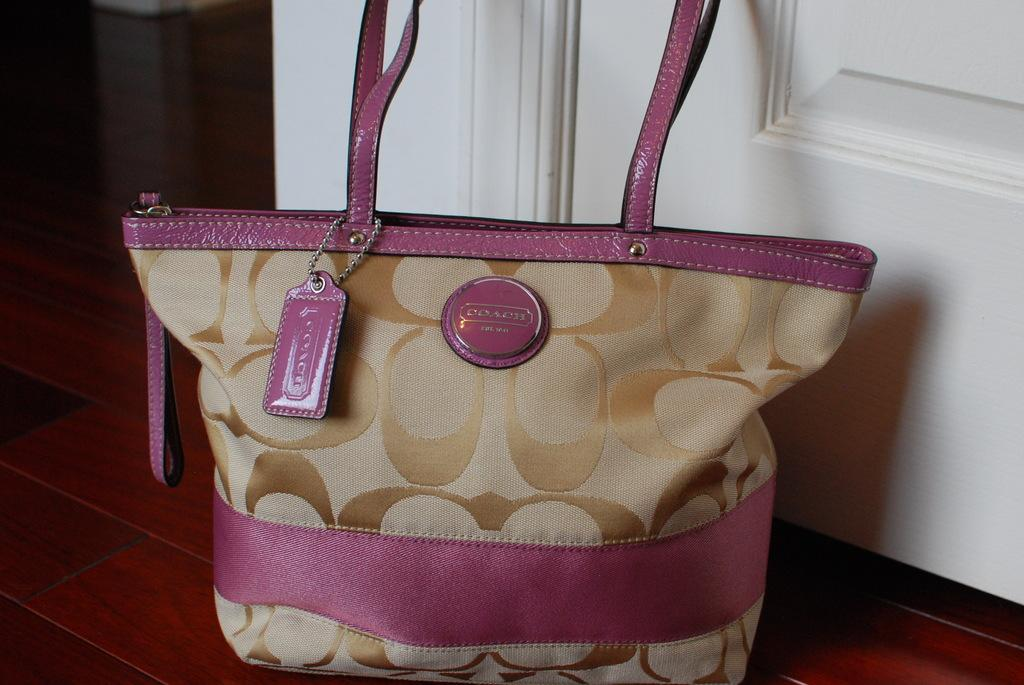What type of accessory is visible in the image? There is a handbag in the image. Can you describe the colors of the handbag? The handbag is pink and brown in color. What type of scent is emitted from the handbag in the image? There is no indication of a scent being emitted from the handbag in the image. 